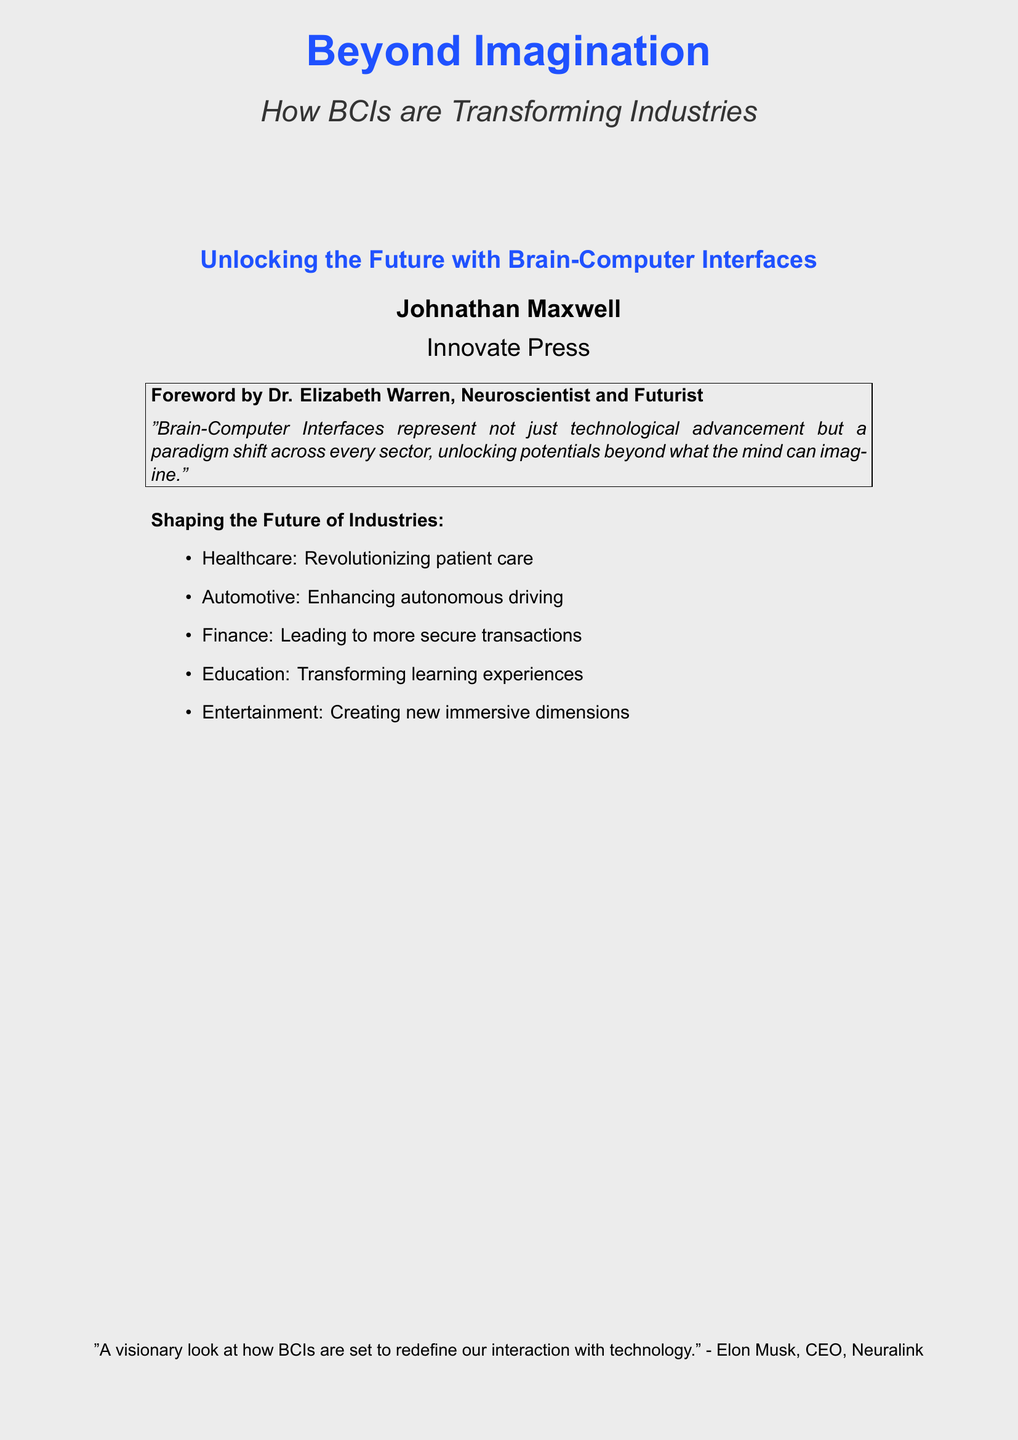What is the book title? The title is prominently displayed on the cover in a large font, stating "Beyond Imagination."
Answer: Beyond Imagination Who is the author? The author's name is presented beneath the title, indicating who wrote the book.
Answer: Johnathan Maxwell What is the publisher's name? The publisher's name appears at the bottom of the cover, identifying the company responsible for the book's publication.
Answer: Innovate Press Which industry is mentioned as revolutionizing patient care? The cover lists various industries, one of which is specifically identified as transforming the healthcare sector.
Answer: Healthcare Who wrote the foreword? The document reveals that Dr. Elizabeth Warren has contributed the foreword, specifying her role.
Answer: Dr. Elizabeth Warren What is one application of BCIs in the automotive industry? The cover suggests enhancements related to autonomous driving in the automotive sector.
Answer: Enhancing autonomous driving Name a quotation about BCIs from Elon Musk. The quote from Elon Musk provides an insightful perspective on BCIs and their future impact.
Answer: "A visionary look at how BCIs are set to redefine our interaction with technology." What does the foreword by Dr. Elizabeth Warren emphasize about BCIs? The statement provides insight into her view of BCIs, signaling their broader implications across sectors.
Answer: A paradigm shift across every sector Which industry is mentioned for creating new immersive dimensions? The industries listed indicate that entertainment is poised for transformation through BCIs.
Answer: Entertainment 